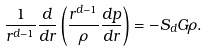Convert formula to latex. <formula><loc_0><loc_0><loc_500><loc_500>\frac { 1 } { r ^ { d - 1 } } \frac { d } { d r } \left ( \frac { r ^ { d - 1 } } { \rho } \frac { d p } { d r } \right ) = - S _ { d } G \rho .</formula> 